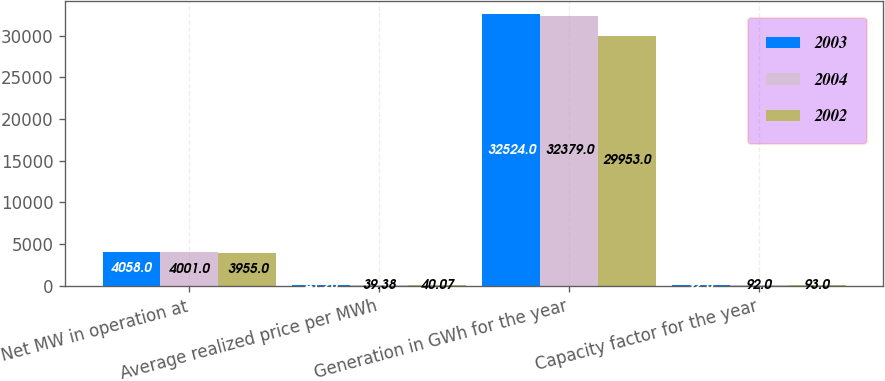<chart> <loc_0><loc_0><loc_500><loc_500><stacked_bar_chart><ecel><fcel>Net MW in operation at<fcel>Average realized price per MWh<fcel>Generation in GWh for the year<fcel>Capacity factor for the year<nl><fcel>2003<fcel>4058<fcel>41.26<fcel>32524<fcel>92<nl><fcel>2004<fcel>4001<fcel>39.38<fcel>32379<fcel>92<nl><fcel>2002<fcel>3955<fcel>40.07<fcel>29953<fcel>93<nl></chart> 